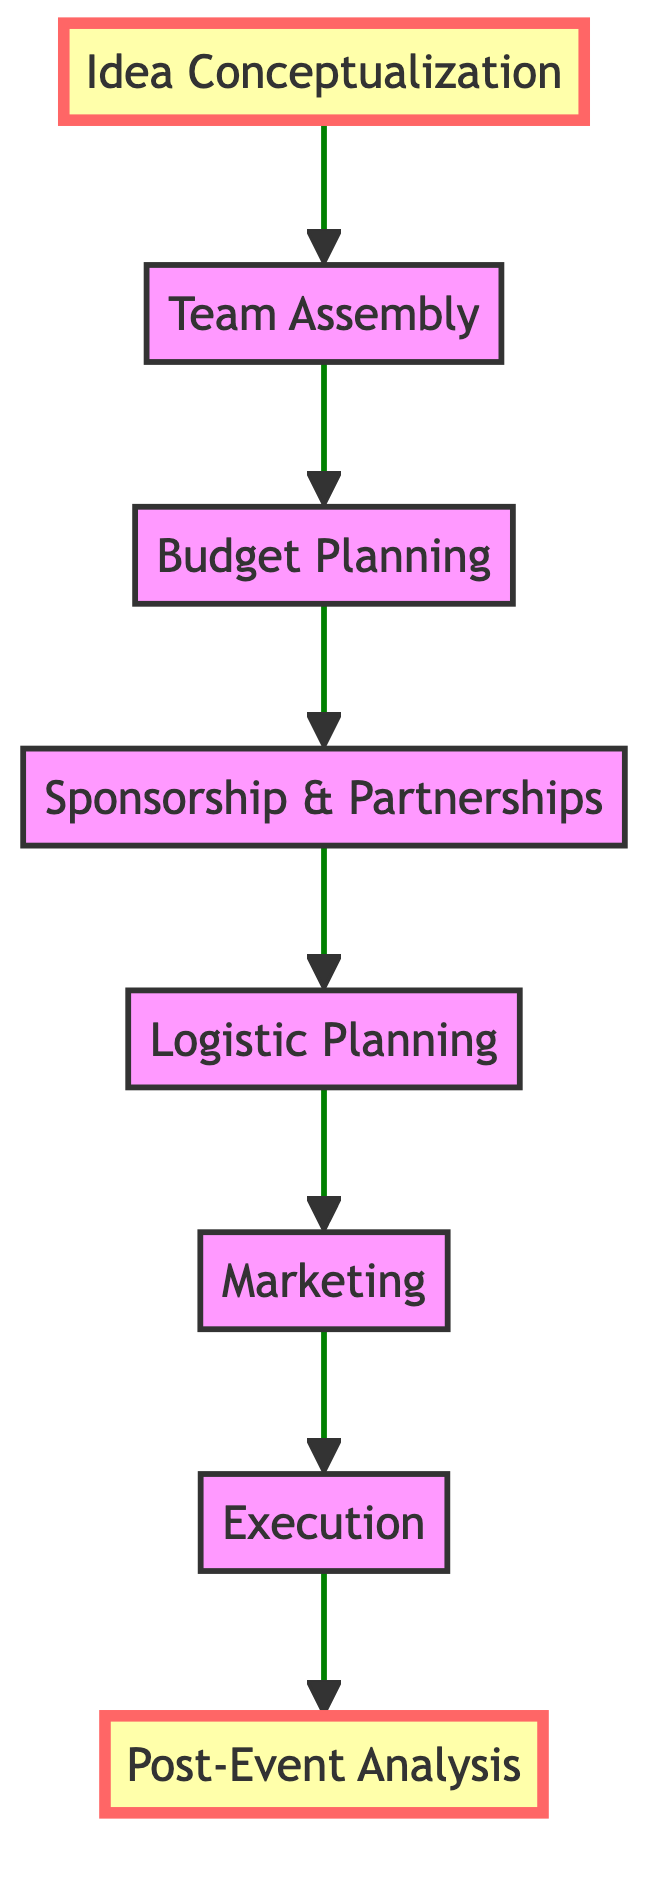What is the first step in the process? The diagram indicates that the first step in the process is "Idea Conceptualization," as it is the bottom node and the starting point for the flow.
Answer: Idea Conceptualization How many total steps are shown in the diagram? By counting each unique node from top to bottom, we find there are eight steps in total: Idea Conceptualization, Team Assembly, Budget Planning, Sponsorship & Partnerships, Logistic Planning, Marketing, Execution, and Post-Event Analysis.
Answer: Eight What is the final step after "Execution"? Looking at the diagram, the final step that follows "Execution" is "Post-Event Analysis," indicating the conclusion of the event planning process.
Answer: Post-Event Analysis Which step comes immediately before "Marketing"? The diagram shows that "Logistic Planning" comes immediately before the "Marketing" step, indicating that logistics are organized prior to marketing efforts.
Answer: Logistic Planning What type of professionals are involved in the "Team Assembly" step? The "Team Assembly" step involves assembling a skilled team of professionals including event planners, marketing experts, safety inspectors, and technical staff.
Answer: Professionals What is the relationship between "Sponsorship & Partnerships" and "Budget Planning"? The diagram illustrates that "Sponsorship & Partnerships" follows "Budget Planning," indicating that sponsorship deals are secured after the budget has been developed.
Answer: Follows What unique aspect is highlighted in "Idea Conceptualization"? The diagram emphasizes that "Idea Conceptualization" focuses on brainstorming and finalizing the event concept, including themes and unique elements that excite participants and spectators.
Answer: Unique elements Which two steps are highlighted in the diagram? In the diagram, "Idea Conceptualization" and "Post-Event Analysis" are specifically highlighted, indicating their importance in the workflow.
Answer: Idea Conceptualization, Post-Event Analysis What is the importance of “Post-Event Analysis”? The diagram describes "Post-Event Analysis" as crucial for evaluating the event's success through metrics such as attendance and athlete feedback, thus identifying areas for improvement.
Answer: Evaluate success 